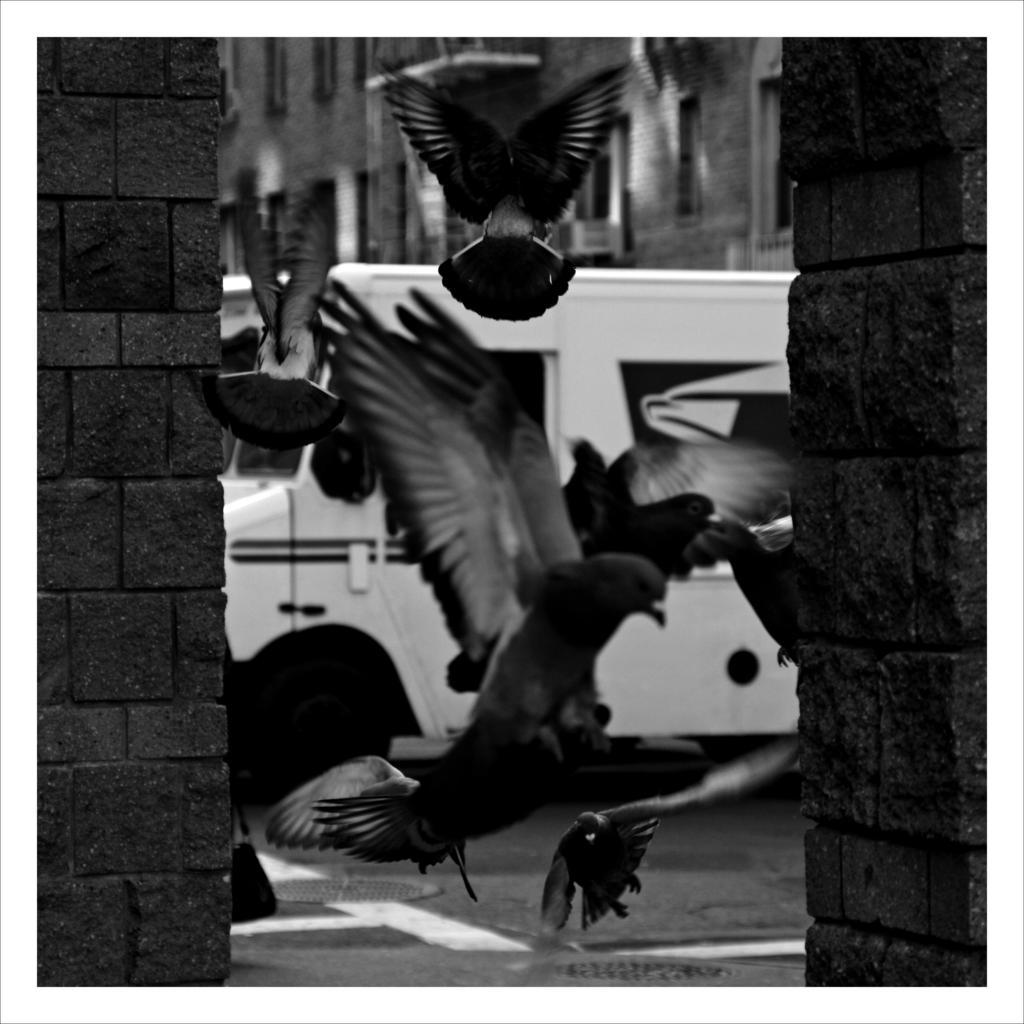In one or two sentences, can you explain what this image depicts? This is a black and white image. These are the birds flying. These look like the pillars. I can see a van, which is parked. In the background, that looks like a building. 